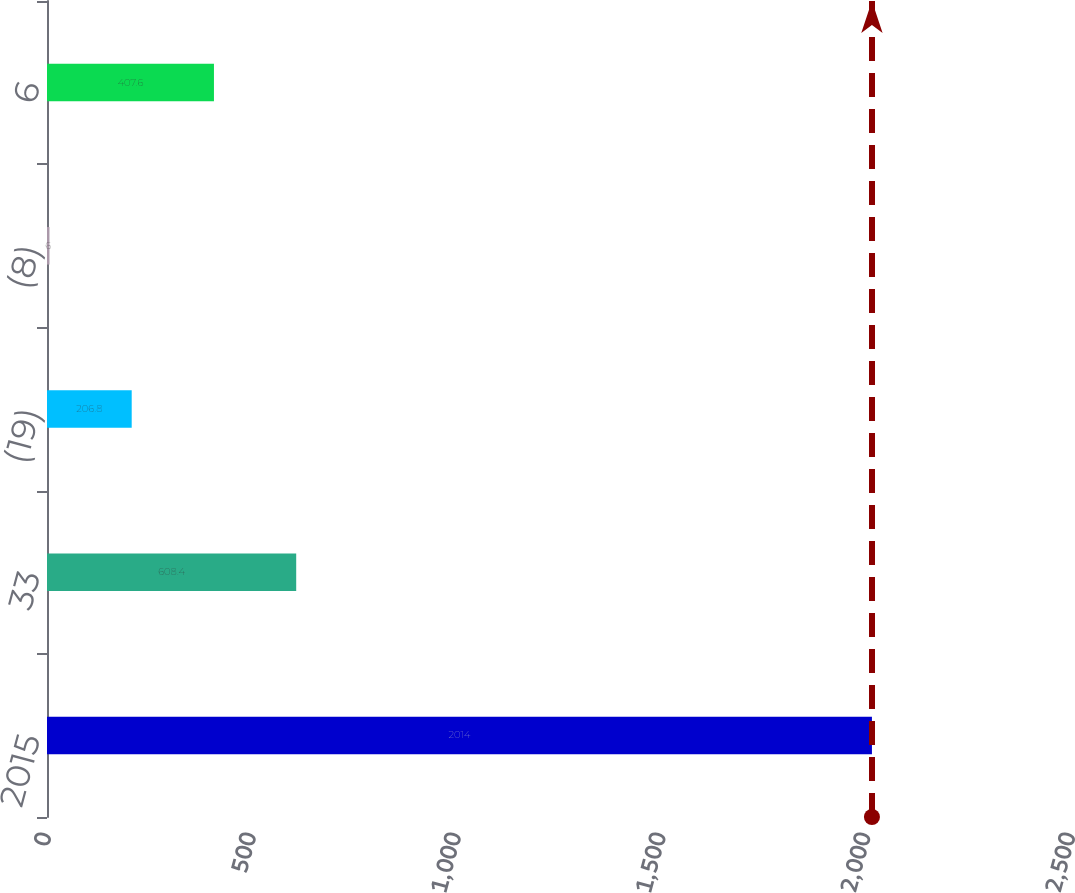Convert chart to OTSL. <chart><loc_0><loc_0><loc_500><loc_500><bar_chart><fcel>2015<fcel>33<fcel>(19)<fcel>(8)<fcel>6<nl><fcel>2014<fcel>608.4<fcel>206.8<fcel>6<fcel>407.6<nl></chart> 